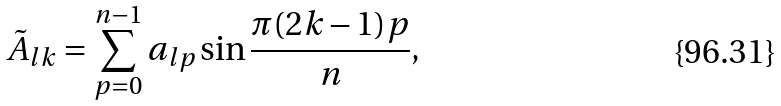<formula> <loc_0><loc_0><loc_500><loc_500>\tilde { A } _ { l k } = \sum _ { p = 0 } ^ { n - 1 } a _ { l p } \sin \frac { \pi ( 2 k - 1 ) p } { n } ,</formula> 